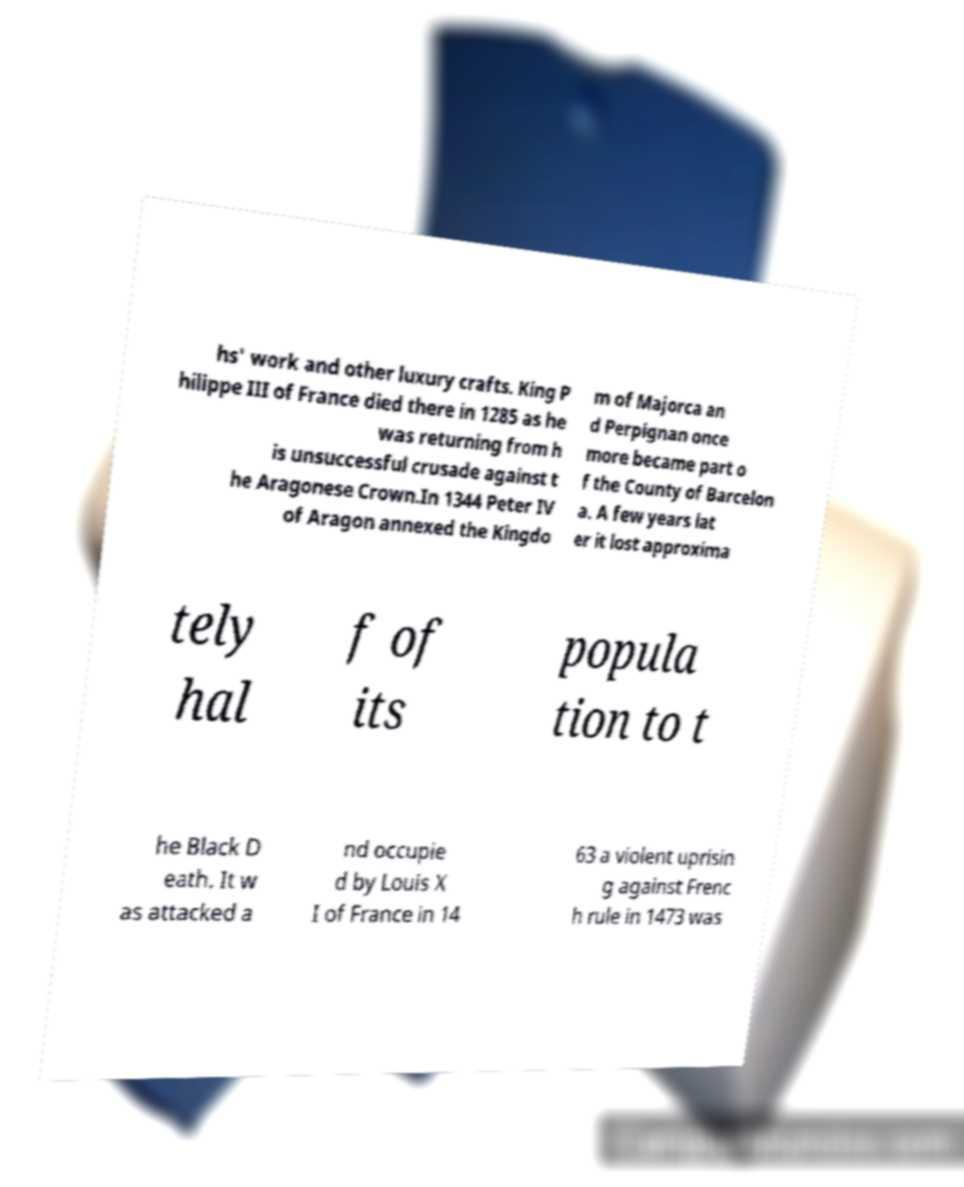Please read and relay the text visible in this image. What does it say? hs' work and other luxury crafts. King P hilippe III of France died there in 1285 as he was returning from h is unsuccessful crusade against t he Aragonese Crown.In 1344 Peter IV of Aragon annexed the Kingdo m of Majorca an d Perpignan once more became part o f the County of Barcelon a. A few years lat er it lost approxima tely hal f of its popula tion to t he Black D eath. It w as attacked a nd occupie d by Louis X I of France in 14 63 a violent uprisin g against Frenc h rule in 1473 was 